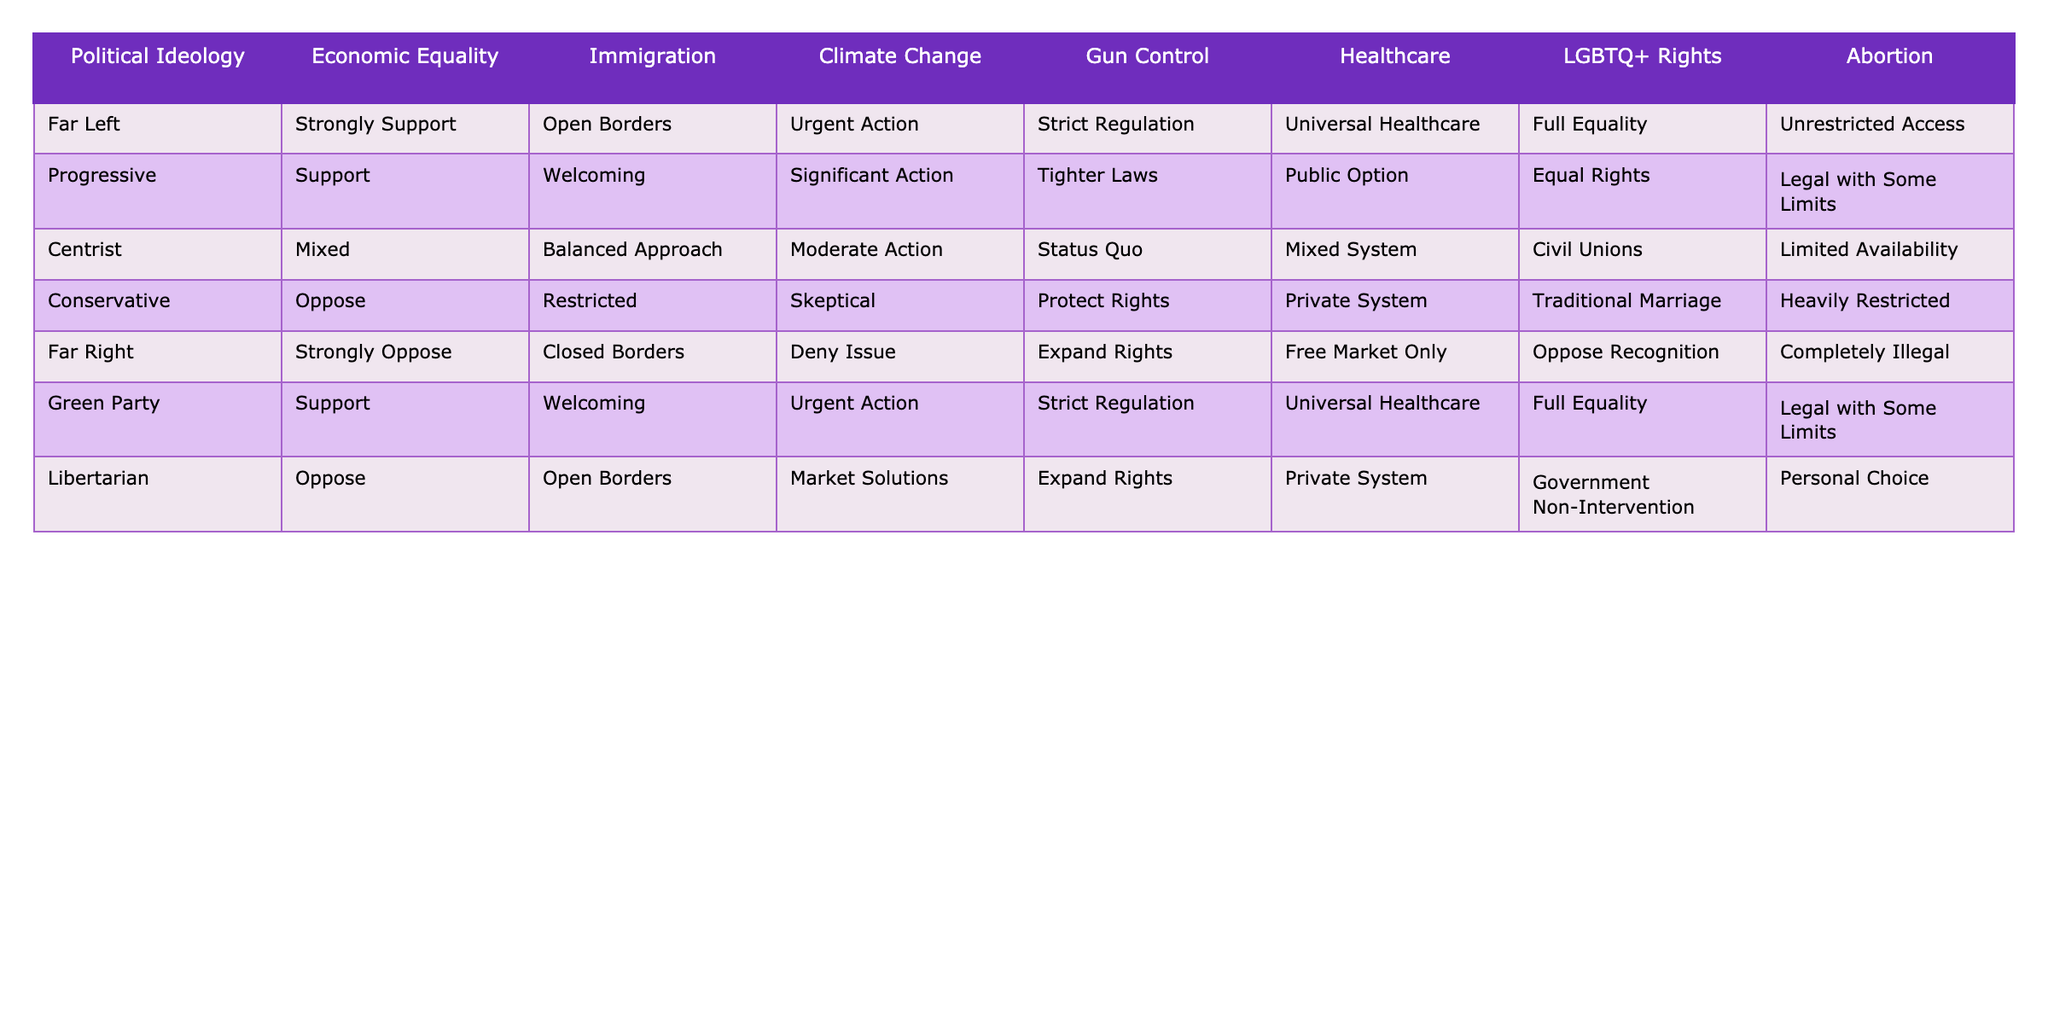What political ideology strongly supports economic equality? By looking at the column for economic equality, the "Far Left" ideology is marked as "Strongly Support."
Answer: Far Left Which ideologies support unrestricted access to abortion? The table shows that "Far Left" and "Green Party" ideologies both advocate for "Unrestricted Access" to abortion.
Answer: Far Left, Green Party What is the stance of the Centrist ideology on gun control? The table indicates that the Centrist ideology has a "Status Quo" position on gun control.
Answer: Status Quo Do any ideologies oppose gun control? The "Far Right" and "Libertarian" ideologies are listed as supporting the expansion of rights regarding gun control, while the "Conservative" ideology upholds "Protect Rights," meaning they do not oppose gun control. Thus, the answer is no.
Answer: No What is the difference in immigration stance between the Far Left and Far Right? The Far Left supports "Open Borders," while the Far Right supports "Closed Borders," leading to a difference in overall immigration policy stance.
Answer: Open Borders vs. Closed Borders Which political ideology offers universal healthcare? Both the "Far Left," "Green Party," and the "Progressive" ideologies support universal healthcare according to the table.
Answer: Far Left, Green Party, Progressive Is there a clear political alignment for strong action on climate change? The "Far Left" and "Green Party" ideologies both call for "Urgent Action" on climate change, showing a strong alignment in this area.
Answer: Yes Which ideology has a mixed approach to economic equality? The "Centrist" ideology displays a "Mixed" stance on economic equality in the provided table.
Answer: Centrist What percentage of ideologies support significant action on climate change? There are six ideologies total: only the "Far Left," "Progressive," and "Green Party" support significant action, thus representing 50% of the ideologies.
Answer: 50% What ideology supports civil unions for LGBTQ+ rights? The "Centrist" ideology is the only one in the table that supports "Civil Unions" for LGBTQ+ rights.
Answer: Centrist 